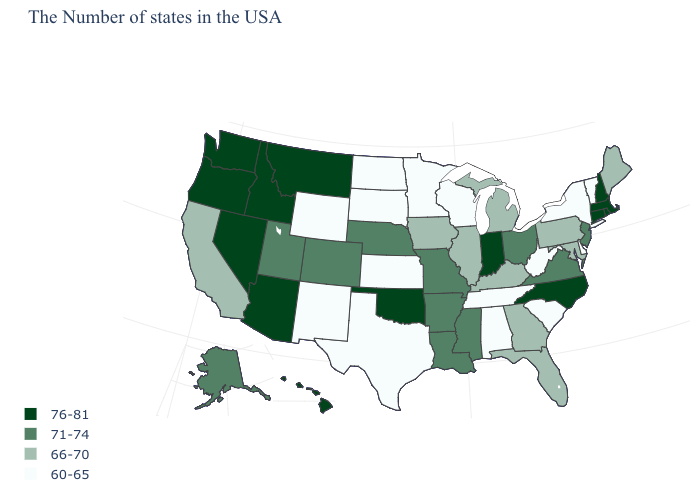Is the legend a continuous bar?
Quick response, please. No. What is the value of Virginia?
Short answer required. 71-74. Among the states that border Kansas , does Oklahoma have the highest value?
Give a very brief answer. Yes. Does the map have missing data?
Give a very brief answer. No. Does Hawaii have the highest value in the West?
Keep it brief. Yes. Name the states that have a value in the range 76-81?
Give a very brief answer. Massachusetts, Rhode Island, New Hampshire, Connecticut, North Carolina, Indiana, Oklahoma, Montana, Arizona, Idaho, Nevada, Washington, Oregon, Hawaii. Name the states that have a value in the range 66-70?
Quick response, please. Maine, Maryland, Pennsylvania, Florida, Georgia, Michigan, Kentucky, Illinois, Iowa, California. What is the highest value in states that border Kansas?
Short answer required. 76-81. Does Tennessee have the highest value in the USA?
Quick response, please. No. How many symbols are there in the legend?
Quick response, please. 4. What is the highest value in the MidWest ?
Write a very short answer. 76-81. Name the states that have a value in the range 76-81?
Quick response, please. Massachusetts, Rhode Island, New Hampshire, Connecticut, North Carolina, Indiana, Oklahoma, Montana, Arizona, Idaho, Nevada, Washington, Oregon, Hawaii. What is the highest value in the USA?
Quick response, please. 76-81. What is the lowest value in the South?
Give a very brief answer. 60-65. 